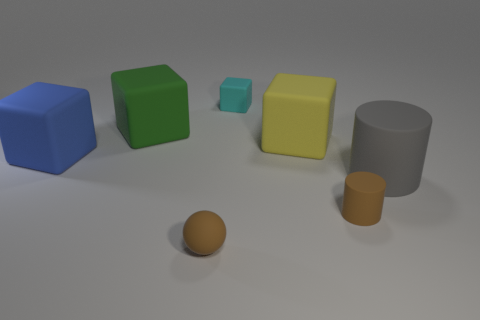There is a tiny brown thing that is left of the small thing behind the large rubber thing in front of the blue rubber thing; what shape is it?
Make the answer very short. Sphere. Are there more purple rubber objects than tiny brown balls?
Your answer should be very brief. No. What material is the green thing that is the same shape as the cyan matte thing?
Make the answer very short. Rubber. Is the number of small cyan rubber things left of the gray thing greater than the number of small purple cylinders?
Keep it short and to the point. Yes. What number of objects are tiny rubber spheres or large matte objects right of the brown ball?
Provide a short and direct response. 3. Is the color of the cylinder to the right of the brown rubber cylinder the same as the matte sphere?
Your response must be concise. No. Are there more tiny brown objects behind the small rubber ball than green things that are in front of the yellow matte thing?
Offer a terse response. Yes. Is there anything else that is the same color as the matte sphere?
Keep it short and to the point. Yes. How many objects are small matte cylinders or brown objects?
Offer a terse response. 2. There is a cylinder that is on the left side of the gray cylinder; is it the same size as the cyan block?
Offer a terse response. Yes. 